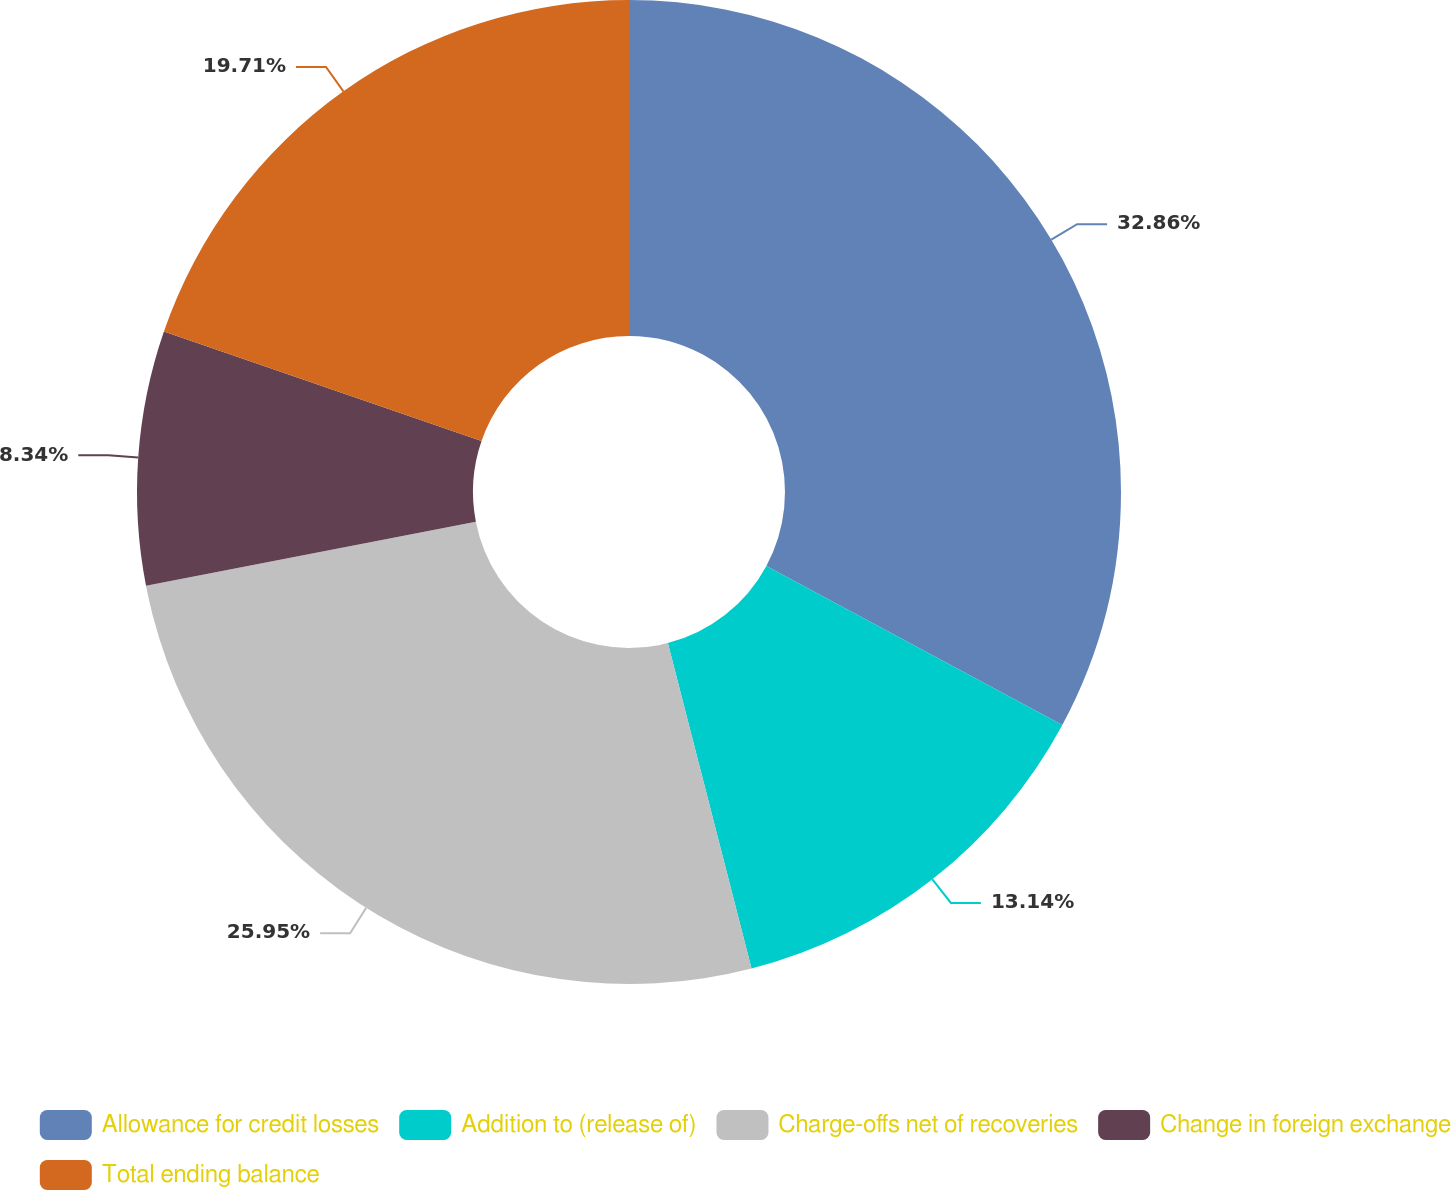Convert chart to OTSL. <chart><loc_0><loc_0><loc_500><loc_500><pie_chart><fcel>Allowance for credit losses<fcel>Addition to (release of)<fcel>Charge-offs net of recoveries<fcel>Change in foreign exchange<fcel>Total ending balance<nl><fcel>32.85%<fcel>13.14%<fcel>25.95%<fcel>8.34%<fcel>19.71%<nl></chart> 